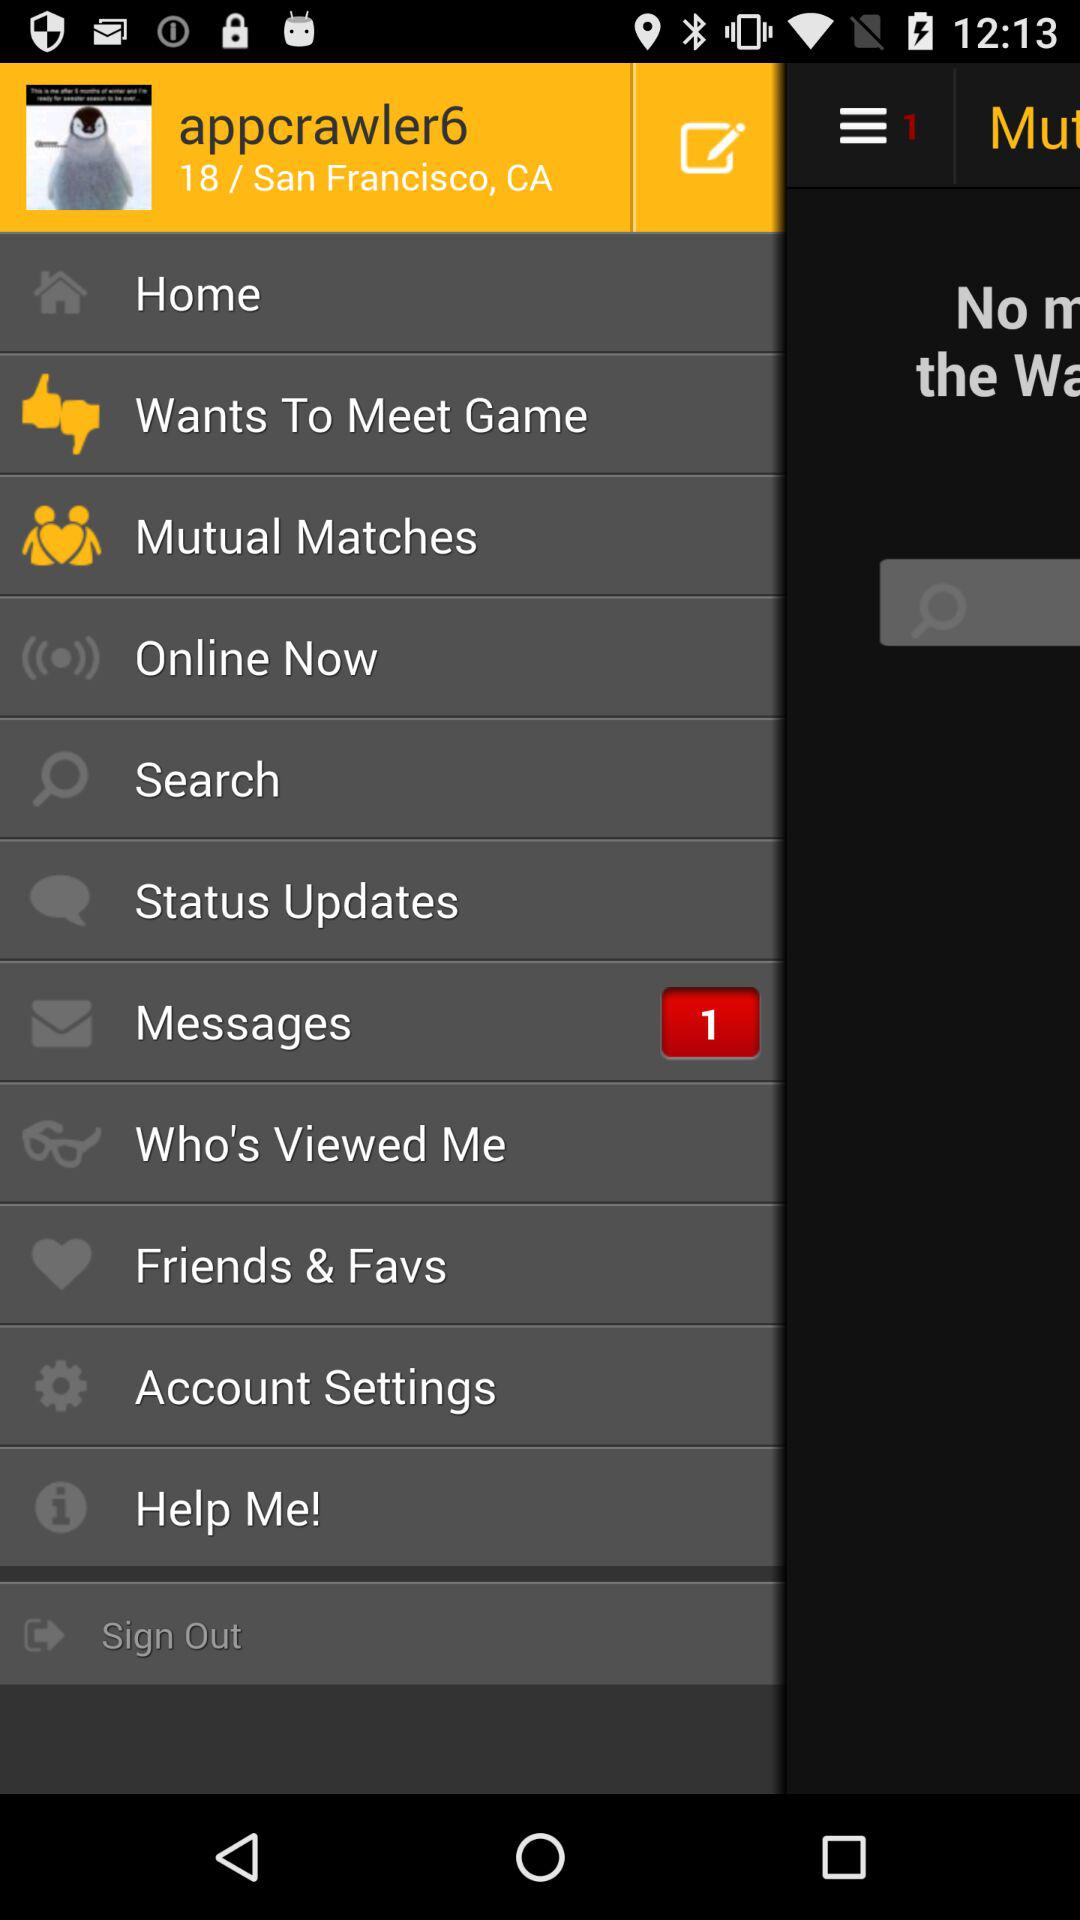What is the address? The address is 18/San Francisco, CA. 